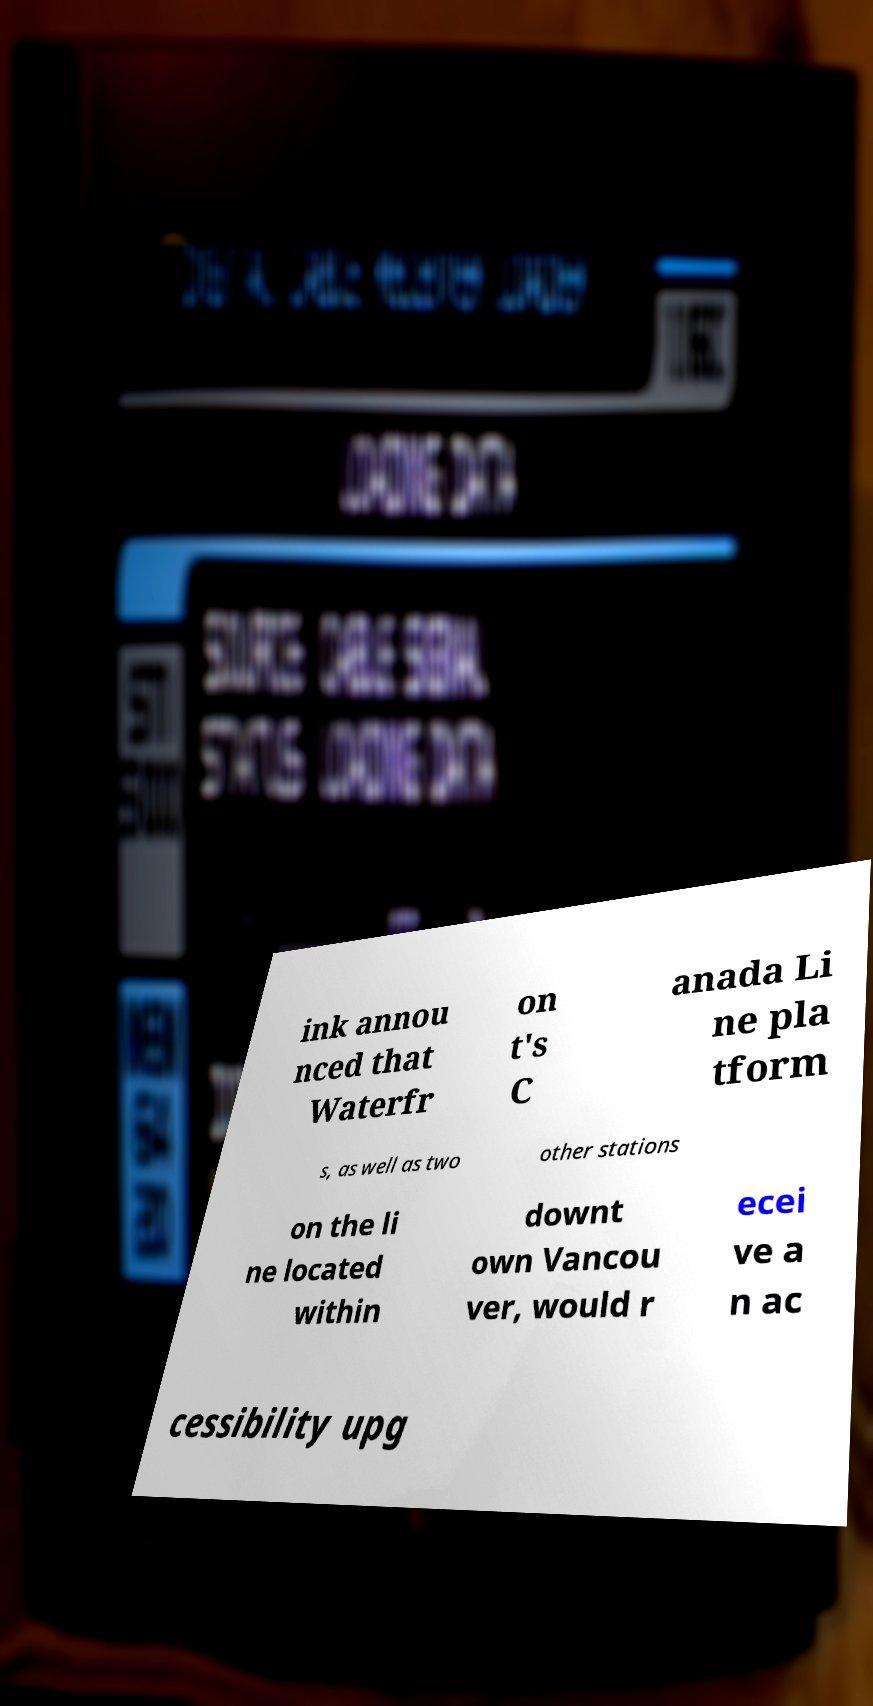Please identify and transcribe the text found in this image. ink annou nced that Waterfr on t's C anada Li ne pla tform s, as well as two other stations on the li ne located within downt own Vancou ver, would r ecei ve a n ac cessibility upg 